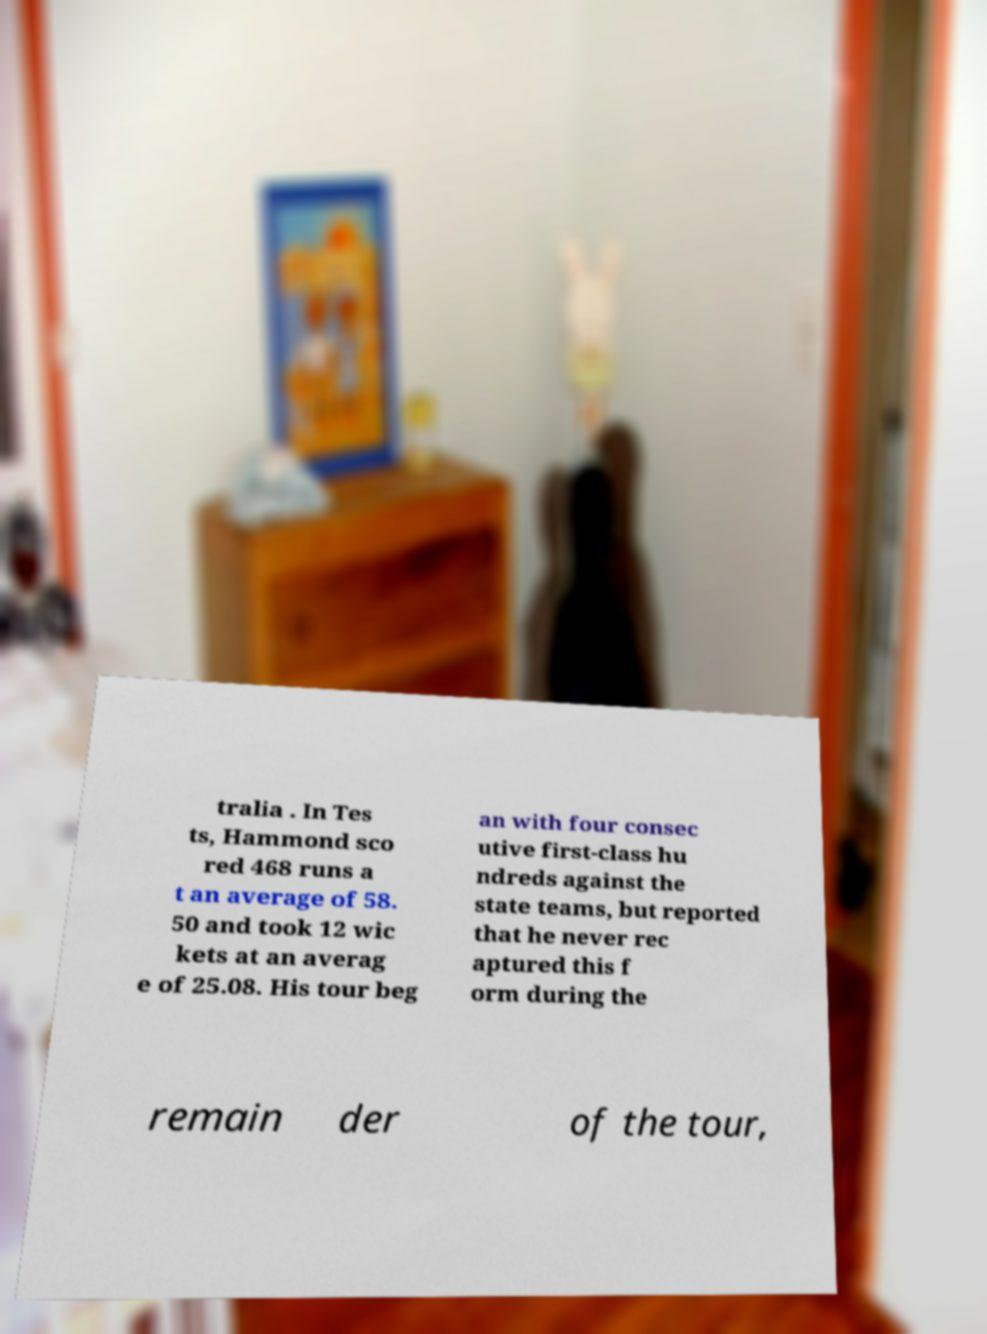I need the written content from this picture converted into text. Can you do that? tralia . In Tes ts, Hammond sco red 468 runs a t an average of 58. 50 and took 12 wic kets at an averag e of 25.08. His tour beg an with four consec utive first-class hu ndreds against the state teams, but reported that he never rec aptured this f orm during the remain der of the tour, 